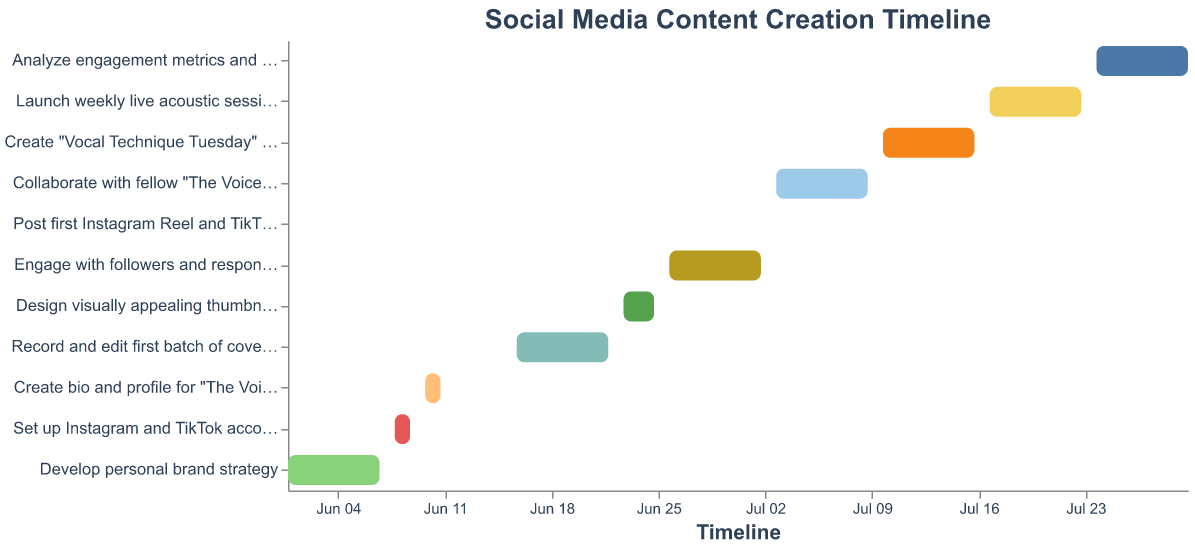How many tasks are listed in the Gantt chart? By looking at the y-axis of the chart, you can count the number of unique tasks listed.
Answer: 11 Which task takes the longest duration? Compare the start and end dates for all the tasks. The task with the greatest span of days is "Record and edit first batch of cover songs" from June 16 to June 22.
Answer: Record and edit first batch of cover songs What is the title of the chart? The title is displayed at the top of the chart.
Answer: Social Media Content Creation Timeline Which tasks start on June 26, 2023? Identify the tasks that have a start date of June 26, 2023, by looking at the x-axis timeline and matching it with the corresponding tasks. These are "Post first Instagram Reel and TikTok video" and "Engage with followers and respond to comments."
Answer: Post first Instagram Reel and TikTok video, Engage with followers and respond to comments Are there any tasks that start and end on the same day? By looking at the chart where the start and end date are the same, "Post first Instagram Reel and TikTok video" meets this criterion as it starts and ends on June 26, 2023.
Answer: Yes, Post first Instagram Reel and TikTok video What is the total duration from the start of the first task to the end of the last task? The first task starts on June 1, 2023, and the last task ends on July 30, 2023. Calculate the total duration from June 1 to July 30.
Answer: 60 days Which tasks overlap with the "Engage with followers and respond to comments" task? Identify the tasks that have a timeline overlapping June 26 to July 2. Overlapping tasks are "Engage with followers and respond to comments," "Post first Instagram Reel and TikTok video," and the latter part of "Design visually appealing thumbnails and graphics."
Answer: Post first Instagram Reel and TikTok video, Design visually appealing thumbnails and graphics How many tasks are scheduled to start in June? Count the tasks that have a start date within June by referencing the x-axis. There are 6 tasks: "Develop personal brand strategy," "Set up Instagram and TikTok accounts," "Create bio and profile for 'The Voice' experience," "Record and edit first batch of cover songs," "Design visually appealing thumbnails and graphics," and "Post first Instagram Reel and TikTok video."
Answer: 6 Which tasks require collaboration with fellow "The Voice" contestants? Look for the task with the specific name "Collaborate with fellow 'The Voice' contestants."
Answer: Collaborate with fellow "The Voice" contestants 